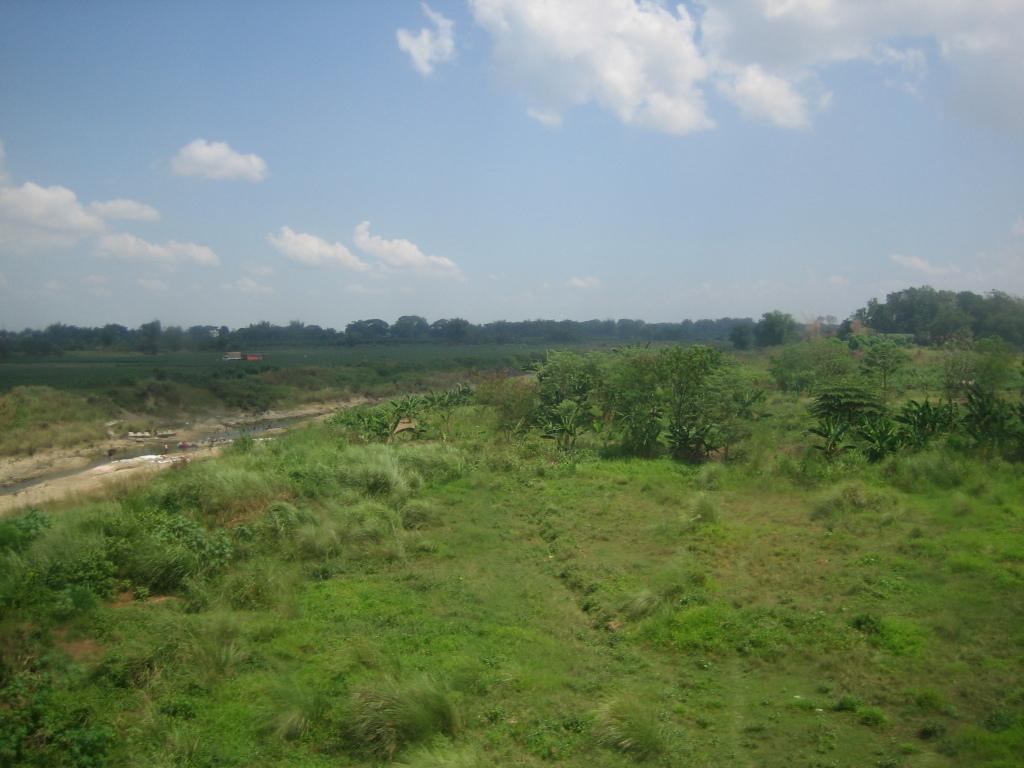Please provide a concise description of this image. In this picture I can observe some plants and grass on the ground. In the background there are trees and clouds in the sky. 